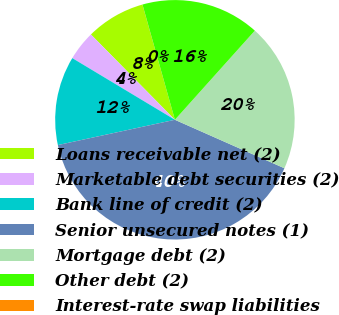Convert chart to OTSL. <chart><loc_0><loc_0><loc_500><loc_500><pie_chart><fcel>Loans receivable net (2)<fcel>Marketable debt securities (2)<fcel>Bank line of credit (2)<fcel>Senior unsecured notes (1)<fcel>Mortgage debt (2)<fcel>Other debt (2)<fcel>Interest-rate swap liabilities<nl><fcel>8.0%<fcel>4.01%<fcel>12.0%<fcel>39.98%<fcel>20.0%<fcel>16.0%<fcel>0.01%<nl></chart> 